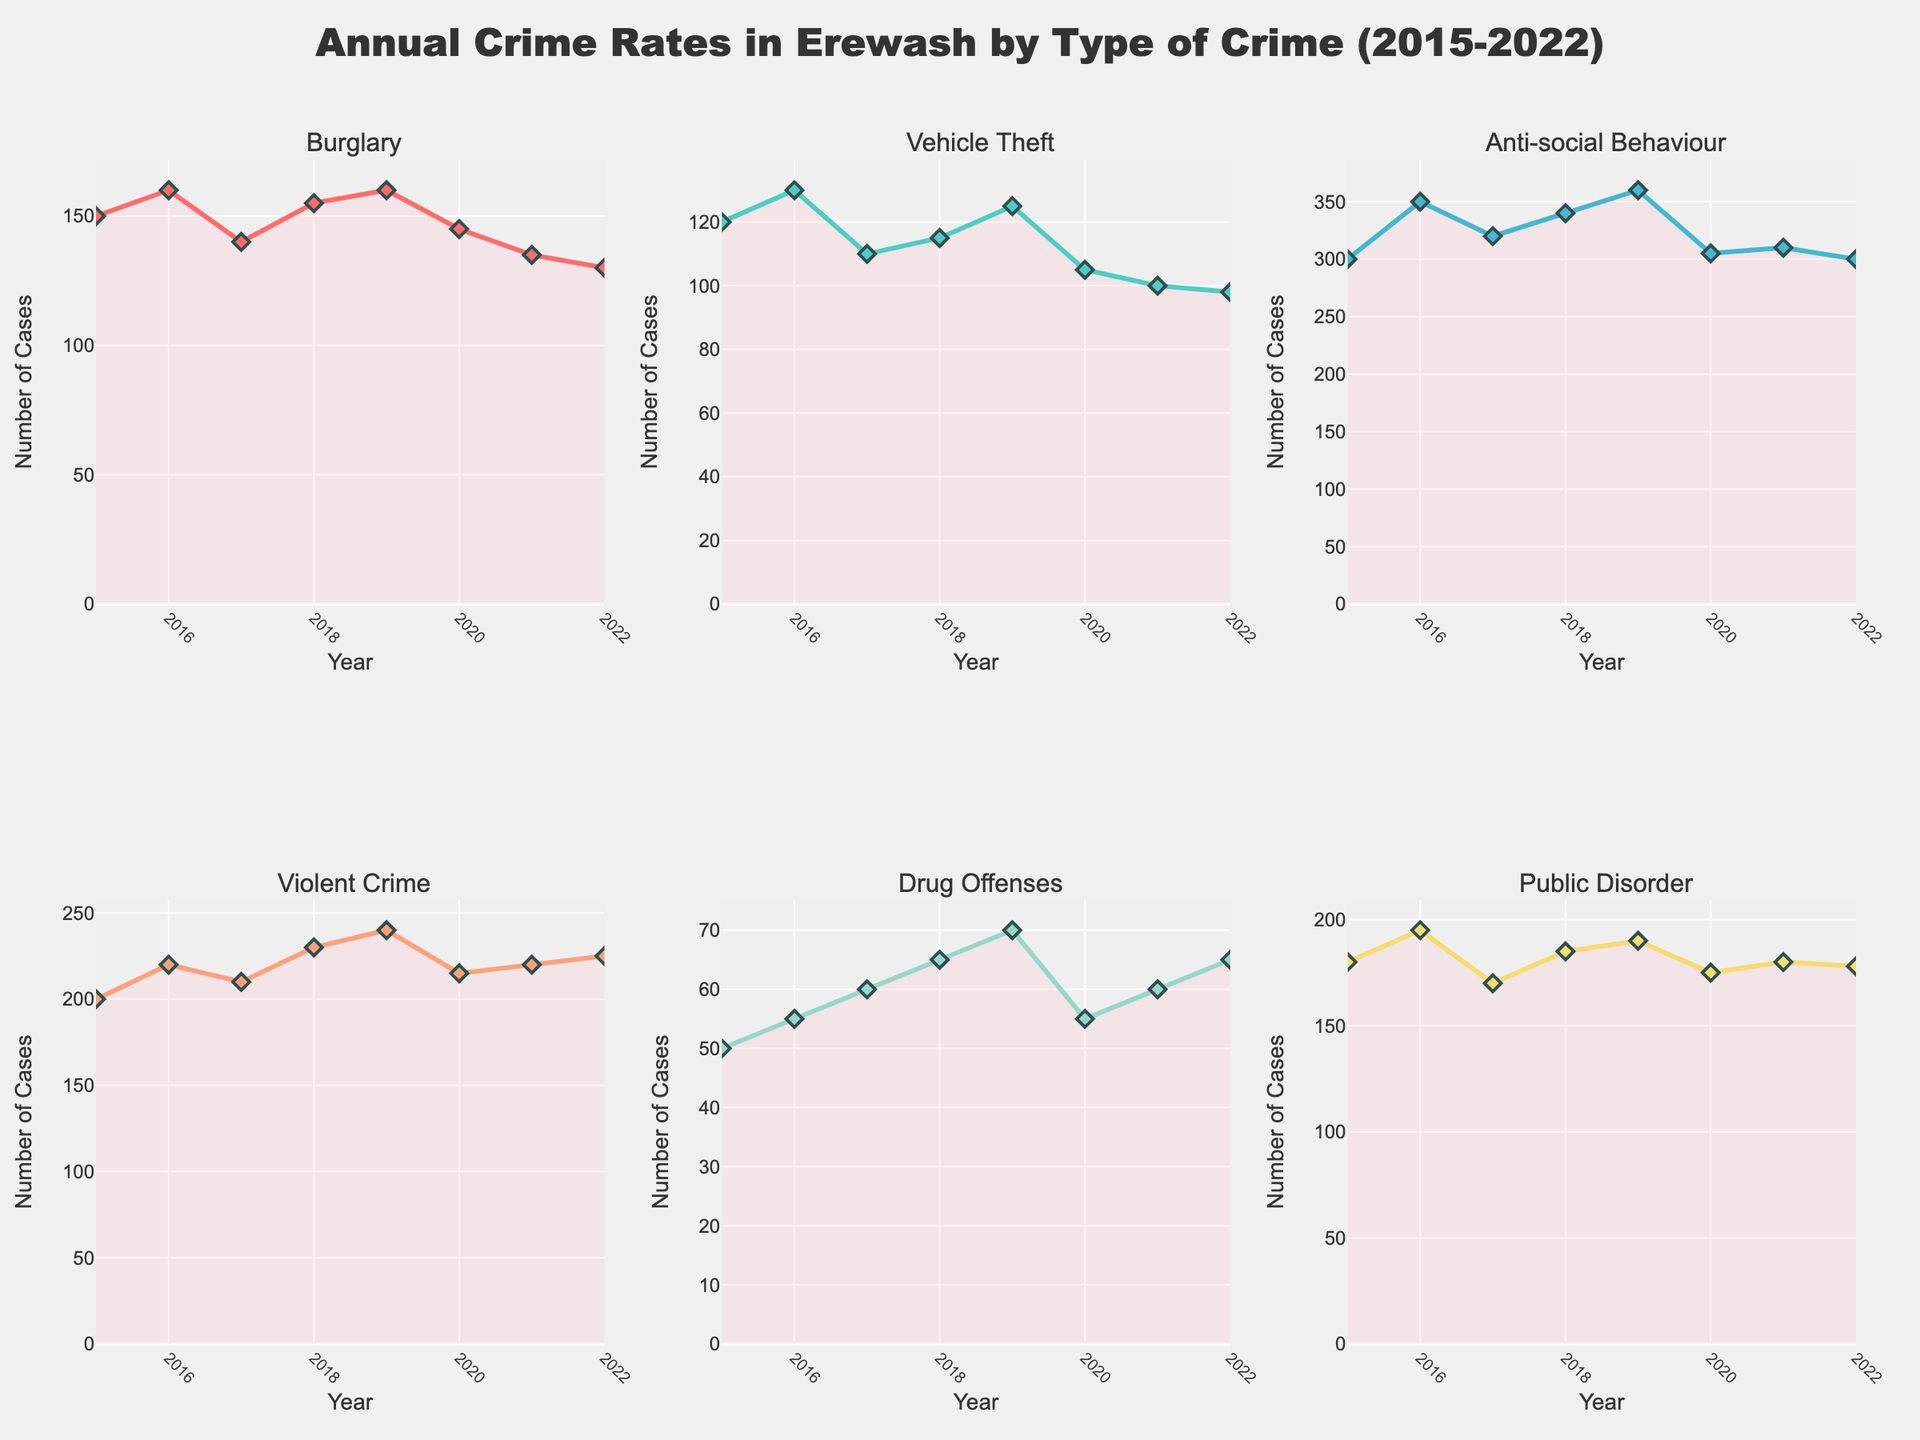What is the title of the plot? The title is typically found at the top of the plot. This plot's title is "Annual Crime Rates in Erewash by Type of Crime (2015-2022)", which indicates the subject and time range of the data.
Answer: Annual Crime Rates in Erewash by Type of Crime (2015-2022) How many types of crimes are displayed in the figure? Count the subplot titles, as each subplot represents a different type of crime: Burglary, Vehicle Theft, Anti-social Behaviour, Violent Crime, Drug Offenses, and Public Disorder. There are 6 subplots.
Answer: 6 What type of crime had the highest number of cases in any single year? For each subplot, find the peak point of the time series lines. Anti-social Behaviour in 2019 had the highest peak with 360 cases.
Answer: Anti-social Behaviour Which year shows the lowest number of Vehicle Theft incidents? Examine the subplot for Vehicle Theft and identify the lowest point on the line, which is in 2022 with 98 cases.
Answer: 2022 Did the number of Burglary cases increase or decrease from 2016 to 2020? Locate the Burglary subplot and compare the values from 2016 (160) to 2020 (145). Since 145 is less than 160, there was a decrease.
Answer: Decrease Which crime type shows the most fluctuations throughout the years? By visually inspecting all subplots, Anti-social Behaviour has the most noticeable up-and-down changes across the plot.
Answer: Anti-social Behaviour What is the difference between the highest and lowest annual cases of Violent Crime between 2015 and 2022? Find the highest point (2022 with 225 cases) and the lowest point (2015 with 200 cases) for Violent Crime. The difference is 225 - 200 = 25 cases.
Answer: 25 cases Which crime type saw a steady increase over time? Look for a subplot where the line generally trends upwards without significant declines. Drug Offenses increase steadily from 2015 (50) to 2022 (65).
Answer: Drug Offenses What was the average number of Public Disorder incidents from 2015 to 2022? Summing the values for Public Disorder (180, 195, 170, 185, 190, 175, 180, 178) equals 1453. Divide by 8 (number of years). The average is 1453 / 8 = 181.625.
Answer: 181.625 